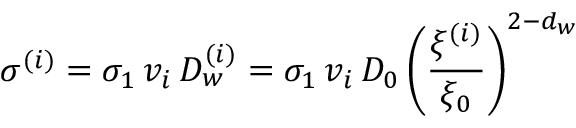<formula> <loc_0><loc_0><loc_500><loc_500>\sigma ^ { ( i ) } = \sigma _ { 1 } \, v _ { i } \, D _ { w } ^ { ( i ) } = \sigma _ { 1 } \, v _ { i } \, D _ { 0 } \left ( \frac { \xi ^ { ( i ) } } { \xi _ { 0 } } \right ) ^ { 2 - d _ { w } }</formula> 